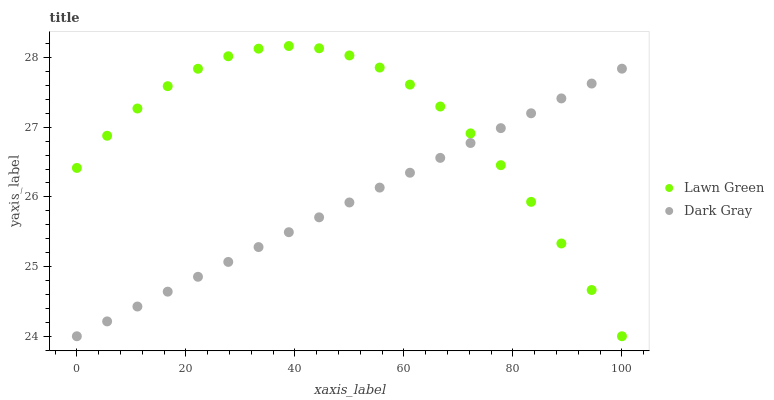Does Dark Gray have the minimum area under the curve?
Answer yes or no. Yes. Does Lawn Green have the maximum area under the curve?
Answer yes or no. Yes. Does Lawn Green have the minimum area under the curve?
Answer yes or no. No. Is Dark Gray the smoothest?
Answer yes or no. Yes. Is Lawn Green the roughest?
Answer yes or no. Yes. Is Lawn Green the smoothest?
Answer yes or no. No. Does Dark Gray have the lowest value?
Answer yes or no. Yes. Does Lawn Green have the highest value?
Answer yes or no. Yes. Does Dark Gray intersect Lawn Green?
Answer yes or no. Yes. Is Dark Gray less than Lawn Green?
Answer yes or no. No. Is Dark Gray greater than Lawn Green?
Answer yes or no. No. 